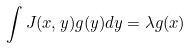<formula> <loc_0><loc_0><loc_500><loc_500>\int J ( x , y ) g ( y ) d y = \lambda g ( x )</formula> 